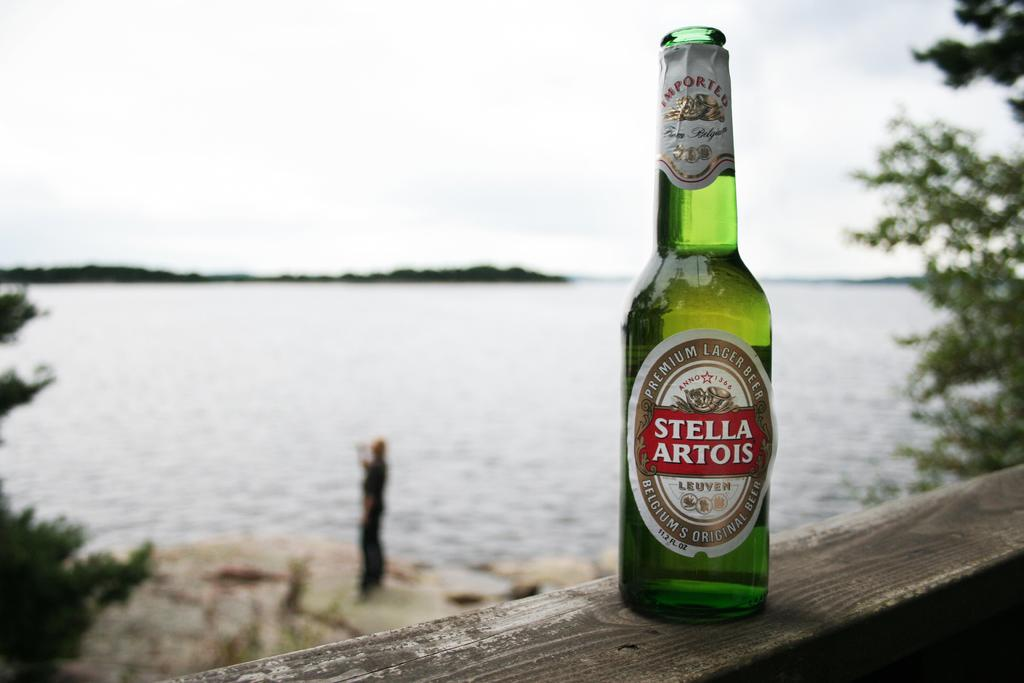What object is attached to the wooden stick in the image? There is a bottle on the wooden stick in the image. What is on the bottle? The bottle has a sticker. What can be seen in the background of the image? There is a sea and trees visible in the background of the image. Are there any people in the image? Yes, there is a man in the background of the image. What type of pancake is the man eating in the image? There is no pancake present in the image, and the man is not shown eating anything. 